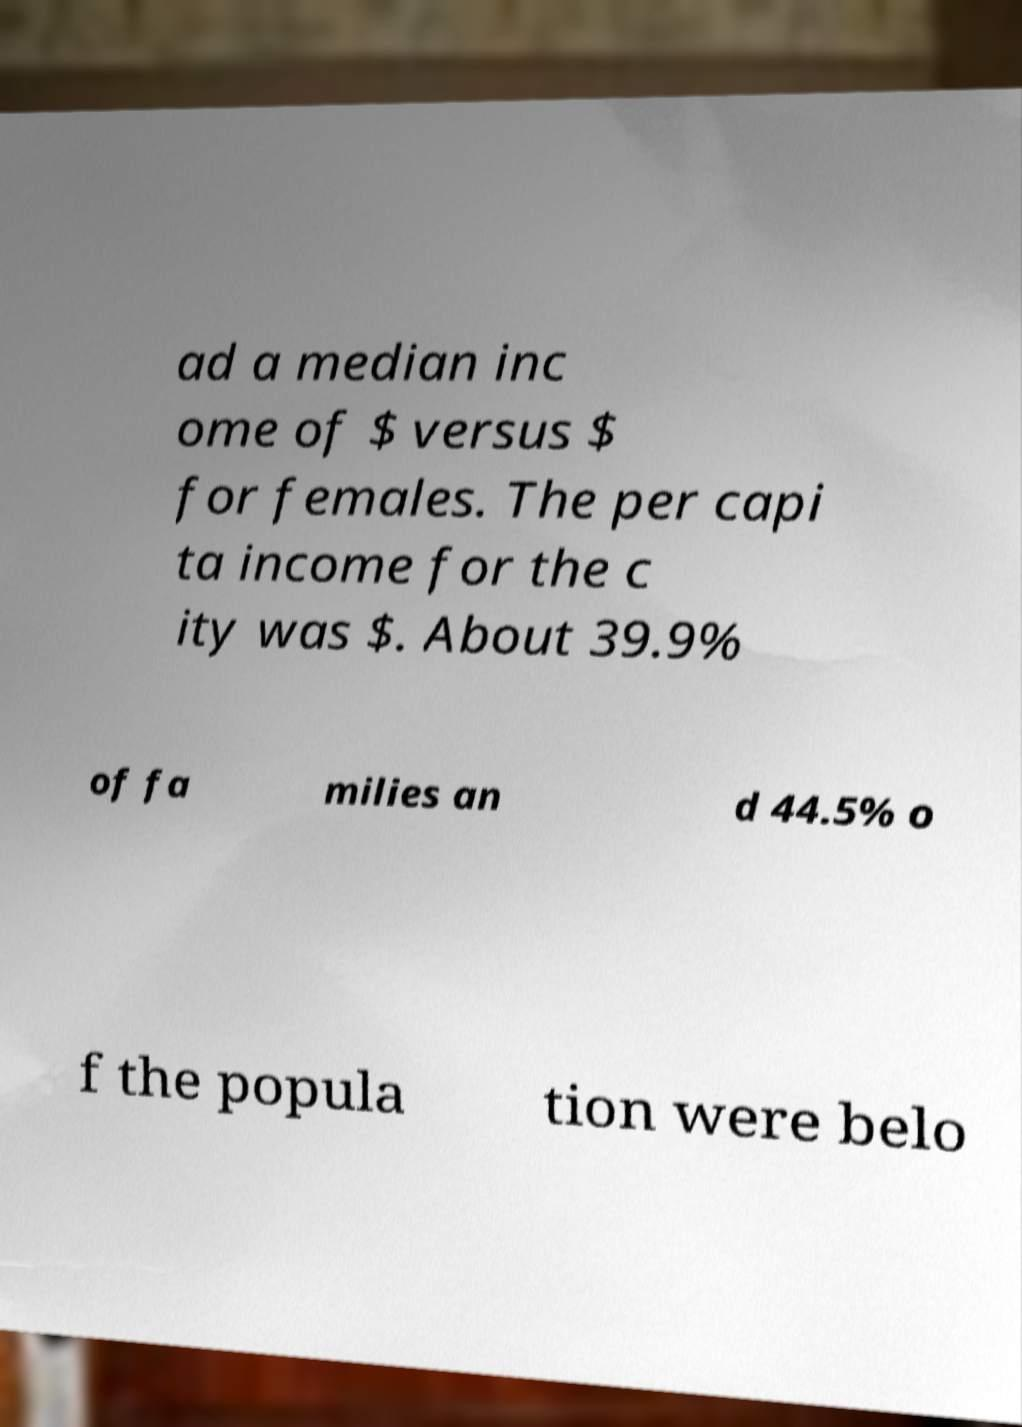Could you extract and type out the text from this image? ad a median inc ome of $ versus $ for females. The per capi ta income for the c ity was $. About 39.9% of fa milies an d 44.5% o f the popula tion were belo 